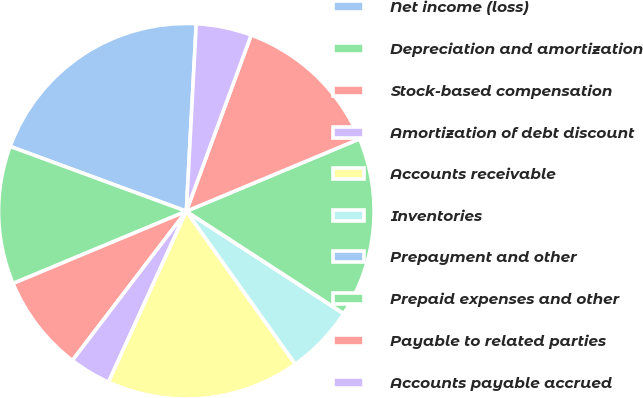Convert chart to OTSL. <chart><loc_0><loc_0><loc_500><loc_500><pie_chart><fcel>Net income (loss)<fcel>Depreciation and amortization<fcel>Stock-based compensation<fcel>Amortization of debt discount<fcel>Accounts receivable<fcel>Inventories<fcel>Prepayment and other<fcel>Prepaid expenses and other<fcel>Payable to related parties<fcel>Accounts payable accrued<nl><fcel>20.23%<fcel>11.9%<fcel>8.33%<fcel>3.58%<fcel>16.66%<fcel>5.96%<fcel>0.01%<fcel>15.47%<fcel>13.09%<fcel>4.77%<nl></chart> 